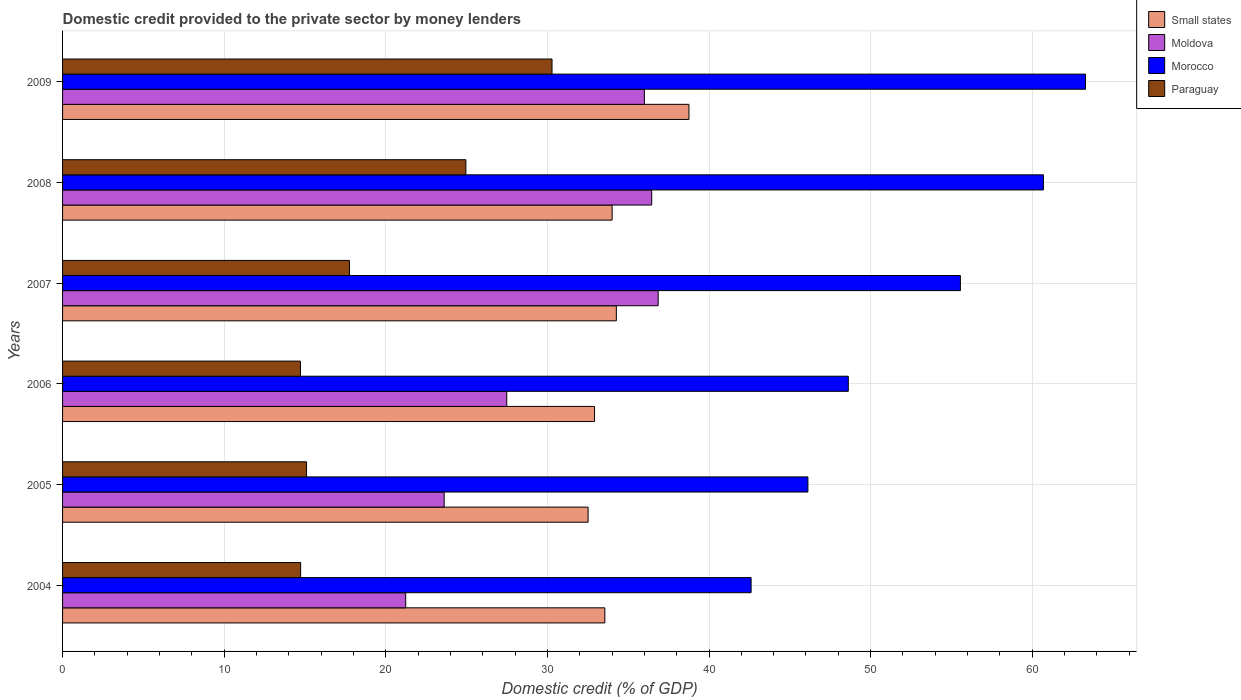How many groups of bars are there?
Your response must be concise. 6. Are the number of bars per tick equal to the number of legend labels?
Your response must be concise. Yes. How many bars are there on the 1st tick from the top?
Provide a succinct answer. 4. What is the domestic credit provided to the private sector by money lenders in Morocco in 2005?
Offer a very short reply. 46.12. Across all years, what is the maximum domestic credit provided to the private sector by money lenders in Small states?
Ensure brevity in your answer.  38.76. Across all years, what is the minimum domestic credit provided to the private sector by money lenders in Morocco?
Make the answer very short. 42.6. In which year was the domestic credit provided to the private sector by money lenders in Morocco maximum?
Offer a terse response. 2009. In which year was the domestic credit provided to the private sector by money lenders in Small states minimum?
Provide a succinct answer. 2005. What is the total domestic credit provided to the private sector by money lenders in Paraguay in the graph?
Your answer should be very brief. 117.55. What is the difference between the domestic credit provided to the private sector by money lenders in Paraguay in 2007 and that in 2009?
Your response must be concise. -12.53. What is the difference between the domestic credit provided to the private sector by money lenders in Paraguay in 2006 and the domestic credit provided to the private sector by money lenders in Small states in 2005?
Offer a terse response. -17.8. What is the average domestic credit provided to the private sector by money lenders in Moldova per year?
Ensure brevity in your answer.  30.27. In the year 2008, what is the difference between the domestic credit provided to the private sector by money lenders in Paraguay and domestic credit provided to the private sector by money lenders in Small states?
Ensure brevity in your answer.  -9.05. What is the ratio of the domestic credit provided to the private sector by money lenders in Moldova in 2005 to that in 2008?
Your response must be concise. 0.65. Is the domestic credit provided to the private sector by money lenders in Paraguay in 2005 less than that in 2007?
Offer a very short reply. Yes. Is the difference between the domestic credit provided to the private sector by money lenders in Paraguay in 2006 and 2009 greater than the difference between the domestic credit provided to the private sector by money lenders in Small states in 2006 and 2009?
Provide a succinct answer. No. What is the difference between the highest and the second highest domestic credit provided to the private sector by money lenders in Small states?
Offer a terse response. 4.49. What is the difference between the highest and the lowest domestic credit provided to the private sector by money lenders in Paraguay?
Give a very brief answer. 15.57. In how many years, is the domestic credit provided to the private sector by money lenders in Small states greater than the average domestic credit provided to the private sector by money lenders in Small states taken over all years?
Offer a very short reply. 1. Is it the case that in every year, the sum of the domestic credit provided to the private sector by money lenders in Moldova and domestic credit provided to the private sector by money lenders in Morocco is greater than the sum of domestic credit provided to the private sector by money lenders in Small states and domestic credit provided to the private sector by money lenders in Paraguay?
Your answer should be very brief. No. What does the 4th bar from the top in 2008 represents?
Your answer should be very brief. Small states. What does the 1st bar from the bottom in 2007 represents?
Your answer should be compact. Small states. Is it the case that in every year, the sum of the domestic credit provided to the private sector by money lenders in Small states and domestic credit provided to the private sector by money lenders in Morocco is greater than the domestic credit provided to the private sector by money lenders in Moldova?
Offer a terse response. Yes. Are all the bars in the graph horizontal?
Offer a terse response. Yes. How many years are there in the graph?
Provide a succinct answer. 6. What is the difference between two consecutive major ticks on the X-axis?
Your answer should be very brief. 10. Are the values on the major ticks of X-axis written in scientific E-notation?
Give a very brief answer. No. Does the graph contain any zero values?
Make the answer very short. No. Does the graph contain grids?
Your answer should be compact. Yes. Where does the legend appear in the graph?
Provide a short and direct response. Top right. How many legend labels are there?
Offer a very short reply. 4. How are the legend labels stacked?
Provide a succinct answer. Vertical. What is the title of the graph?
Your answer should be very brief. Domestic credit provided to the private sector by money lenders. What is the label or title of the X-axis?
Your response must be concise. Domestic credit (% of GDP). What is the label or title of the Y-axis?
Ensure brevity in your answer.  Years. What is the Domestic credit (% of GDP) in Small states in 2004?
Keep it short and to the point. 33.56. What is the Domestic credit (% of GDP) in Moldova in 2004?
Your answer should be very brief. 21.23. What is the Domestic credit (% of GDP) in Morocco in 2004?
Your answer should be compact. 42.6. What is the Domestic credit (% of GDP) of Paraguay in 2004?
Offer a very short reply. 14.73. What is the Domestic credit (% of GDP) of Small states in 2005?
Your answer should be very brief. 32.52. What is the Domestic credit (% of GDP) of Moldova in 2005?
Keep it short and to the point. 23.61. What is the Domestic credit (% of GDP) in Morocco in 2005?
Give a very brief answer. 46.12. What is the Domestic credit (% of GDP) of Paraguay in 2005?
Your response must be concise. 15.1. What is the Domestic credit (% of GDP) of Small states in 2006?
Ensure brevity in your answer.  32.92. What is the Domestic credit (% of GDP) of Moldova in 2006?
Offer a terse response. 27.48. What is the Domestic credit (% of GDP) in Morocco in 2006?
Give a very brief answer. 48.62. What is the Domestic credit (% of GDP) in Paraguay in 2006?
Offer a very short reply. 14.72. What is the Domestic credit (% of GDP) in Small states in 2007?
Your answer should be very brief. 34.27. What is the Domestic credit (% of GDP) in Moldova in 2007?
Your answer should be very brief. 36.86. What is the Domestic credit (% of GDP) of Morocco in 2007?
Ensure brevity in your answer.  55.55. What is the Domestic credit (% of GDP) of Paraguay in 2007?
Ensure brevity in your answer.  17.76. What is the Domestic credit (% of GDP) in Small states in 2008?
Make the answer very short. 34.01. What is the Domestic credit (% of GDP) of Moldova in 2008?
Offer a terse response. 36.46. What is the Domestic credit (% of GDP) of Morocco in 2008?
Provide a succinct answer. 60.69. What is the Domestic credit (% of GDP) in Paraguay in 2008?
Provide a short and direct response. 24.96. What is the Domestic credit (% of GDP) of Small states in 2009?
Keep it short and to the point. 38.76. What is the Domestic credit (% of GDP) of Moldova in 2009?
Make the answer very short. 36. What is the Domestic credit (% of GDP) of Morocco in 2009?
Offer a terse response. 63.3. What is the Domestic credit (% of GDP) in Paraguay in 2009?
Make the answer very short. 30.29. Across all years, what is the maximum Domestic credit (% of GDP) of Small states?
Provide a succinct answer. 38.76. Across all years, what is the maximum Domestic credit (% of GDP) in Moldova?
Keep it short and to the point. 36.86. Across all years, what is the maximum Domestic credit (% of GDP) in Morocco?
Give a very brief answer. 63.3. Across all years, what is the maximum Domestic credit (% of GDP) of Paraguay?
Offer a very short reply. 30.29. Across all years, what is the minimum Domestic credit (% of GDP) of Small states?
Offer a terse response. 32.52. Across all years, what is the minimum Domestic credit (% of GDP) in Moldova?
Keep it short and to the point. 21.23. Across all years, what is the minimum Domestic credit (% of GDP) in Morocco?
Offer a terse response. 42.6. Across all years, what is the minimum Domestic credit (% of GDP) of Paraguay?
Provide a succinct answer. 14.72. What is the total Domestic credit (% of GDP) in Small states in the graph?
Offer a very short reply. 206.03. What is the total Domestic credit (% of GDP) of Moldova in the graph?
Give a very brief answer. 181.64. What is the total Domestic credit (% of GDP) in Morocco in the graph?
Provide a succinct answer. 316.89. What is the total Domestic credit (% of GDP) of Paraguay in the graph?
Your answer should be compact. 117.55. What is the difference between the Domestic credit (% of GDP) in Small states in 2004 and that in 2005?
Offer a very short reply. 1.04. What is the difference between the Domestic credit (% of GDP) of Moldova in 2004 and that in 2005?
Ensure brevity in your answer.  -2.38. What is the difference between the Domestic credit (% of GDP) in Morocco in 2004 and that in 2005?
Give a very brief answer. -3.52. What is the difference between the Domestic credit (% of GDP) of Paraguay in 2004 and that in 2005?
Give a very brief answer. -0.37. What is the difference between the Domestic credit (% of GDP) of Small states in 2004 and that in 2006?
Your answer should be compact. 0.64. What is the difference between the Domestic credit (% of GDP) in Moldova in 2004 and that in 2006?
Keep it short and to the point. -6.25. What is the difference between the Domestic credit (% of GDP) in Morocco in 2004 and that in 2006?
Your response must be concise. -6.02. What is the difference between the Domestic credit (% of GDP) in Paraguay in 2004 and that in 2006?
Your answer should be very brief. 0.01. What is the difference between the Domestic credit (% of GDP) of Small states in 2004 and that in 2007?
Ensure brevity in your answer.  -0.71. What is the difference between the Domestic credit (% of GDP) in Moldova in 2004 and that in 2007?
Provide a short and direct response. -15.62. What is the difference between the Domestic credit (% of GDP) in Morocco in 2004 and that in 2007?
Provide a succinct answer. -12.95. What is the difference between the Domestic credit (% of GDP) in Paraguay in 2004 and that in 2007?
Your answer should be very brief. -3.02. What is the difference between the Domestic credit (% of GDP) in Small states in 2004 and that in 2008?
Provide a succinct answer. -0.45. What is the difference between the Domestic credit (% of GDP) of Moldova in 2004 and that in 2008?
Make the answer very short. -15.22. What is the difference between the Domestic credit (% of GDP) of Morocco in 2004 and that in 2008?
Offer a terse response. -18.09. What is the difference between the Domestic credit (% of GDP) of Paraguay in 2004 and that in 2008?
Provide a succinct answer. -10.23. What is the difference between the Domestic credit (% of GDP) of Small states in 2004 and that in 2009?
Your response must be concise. -5.2. What is the difference between the Domestic credit (% of GDP) in Moldova in 2004 and that in 2009?
Keep it short and to the point. -14.77. What is the difference between the Domestic credit (% of GDP) in Morocco in 2004 and that in 2009?
Your response must be concise. -20.69. What is the difference between the Domestic credit (% of GDP) of Paraguay in 2004 and that in 2009?
Provide a short and direct response. -15.56. What is the difference between the Domestic credit (% of GDP) in Small states in 2005 and that in 2006?
Your answer should be very brief. -0.4. What is the difference between the Domestic credit (% of GDP) of Moldova in 2005 and that in 2006?
Keep it short and to the point. -3.87. What is the difference between the Domestic credit (% of GDP) of Morocco in 2005 and that in 2006?
Provide a succinct answer. -2.5. What is the difference between the Domestic credit (% of GDP) of Paraguay in 2005 and that in 2006?
Provide a short and direct response. 0.38. What is the difference between the Domestic credit (% of GDP) in Small states in 2005 and that in 2007?
Your answer should be compact. -1.75. What is the difference between the Domestic credit (% of GDP) of Moldova in 2005 and that in 2007?
Offer a terse response. -13.24. What is the difference between the Domestic credit (% of GDP) in Morocco in 2005 and that in 2007?
Your response must be concise. -9.43. What is the difference between the Domestic credit (% of GDP) in Paraguay in 2005 and that in 2007?
Give a very brief answer. -2.66. What is the difference between the Domestic credit (% of GDP) of Small states in 2005 and that in 2008?
Offer a very short reply. -1.49. What is the difference between the Domestic credit (% of GDP) in Moldova in 2005 and that in 2008?
Make the answer very short. -12.84. What is the difference between the Domestic credit (% of GDP) in Morocco in 2005 and that in 2008?
Offer a very short reply. -14.57. What is the difference between the Domestic credit (% of GDP) of Paraguay in 2005 and that in 2008?
Provide a succinct answer. -9.86. What is the difference between the Domestic credit (% of GDP) of Small states in 2005 and that in 2009?
Your response must be concise. -6.24. What is the difference between the Domestic credit (% of GDP) in Moldova in 2005 and that in 2009?
Your answer should be very brief. -12.39. What is the difference between the Domestic credit (% of GDP) in Morocco in 2005 and that in 2009?
Your answer should be very brief. -17.18. What is the difference between the Domestic credit (% of GDP) of Paraguay in 2005 and that in 2009?
Keep it short and to the point. -15.19. What is the difference between the Domestic credit (% of GDP) in Small states in 2006 and that in 2007?
Ensure brevity in your answer.  -1.35. What is the difference between the Domestic credit (% of GDP) in Moldova in 2006 and that in 2007?
Offer a terse response. -9.37. What is the difference between the Domestic credit (% of GDP) of Morocco in 2006 and that in 2007?
Provide a succinct answer. -6.93. What is the difference between the Domestic credit (% of GDP) of Paraguay in 2006 and that in 2007?
Your answer should be very brief. -3.04. What is the difference between the Domestic credit (% of GDP) in Small states in 2006 and that in 2008?
Provide a succinct answer. -1.09. What is the difference between the Domestic credit (% of GDP) in Moldova in 2006 and that in 2008?
Keep it short and to the point. -8.97. What is the difference between the Domestic credit (% of GDP) in Morocco in 2006 and that in 2008?
Offer a terse response. -12.07. What is the difference between the Domestic credit (% of GDP) in Paraguay in 2006 and that in 2008?
Your response must be concise. -10.24. What is the difference between the Domestic credit (% of GDP) in Small states in 2006 and that in 2009?
Give a very brief answer. -5.84. What is the difference between the Domestic credit (% of GDP) in Moldova in 2006 and that in 2009?
Keep it short and to the point. -8.52. What is the difference between the Domestic credit (% of GDP) of Morocco in 2006 and that in 2009?
Give a very brief answer. -14.68. What is the difference between the Domestic credit (% of GDP) of Paraguay in 2006 and that in 2009?
Offer a terse response. -15.57. What is the difference between the Domestic credit (% of GDP) in Small states in 2007 and that in 2008?
Keep it short and to the point. 0.26. What is the difference between the Domestic credit (% of GDP) in Moldova in 2007 and that in 2008?
Provide a short and direct response. 0.4. What is the difference between the Domestic credit (% of GDP) in Morocco in 2007 and that in 2008?
Make the answer very short. -5.14. What is the difference between the Domestic credit (% of GDP) of Paraguay in 2007 and that in 2008?
Your answer should be very brief. -7.2. What is the difference between the Domestic credit (% of GDP) of Small states in 2007 and that in 2009?
Ensure brevity in your answer.  -4.49. What is the difference between the Domestic credit (% of GDP) in Moldova in 2007 and that in 2009?
Provide a short and direct response. 0.85. What is the difference between the Domestic credit (% of GDP) in Morocco in 2007 and that in 2009?
Offer a terse response. -7.74. What is the difference between the Domestic credit (% of GDP) of Paraguay in 2007 and that in 2009?
Your response must be concise. -12.53. What is the difference between the Domestic credit (% of GDP) in Small states in 2008 and that in 2009?
Your answer should be very brief. -4.75. What is the difference between the Domestic credit (% of GDP) in Moldova in 2008 and that in 2009?
Ensure brevity in your answer.  0.45. What is the difference between the Domestic credit (% of GDP) of Morocco in 2008 and that in 2009?
Your response must be concise. -2.6. What is the difference between the Domestic credit (% of GDP) in Paraguay in 2008 and that in 2009?
Offer a terse response. -5.33. What is the difference between the Domestic credit (% of GDP) in Small states in 2004 and the Domestic credit (% of GDP) in Moldova in 2005?
Your answer should be very brief. 9.94. What is the difference between the Domestic credit (% of GDP) of Small states in 2004 and the Domestic credit (% of GDP) of Morocco in 2005?
Your answer should be very brief. -12.56. What is the difference between the Domestic credit (% of GDP) in Small states in 2004 and the Domestic credit (% of GDP) in Paraguay in 2005?
Ensure brevity in your answer.  18.46. What is the difference between the Domestic credit (% of GDP) in Moldova in 2004 and the Domestic credit (% of GDP) in Morocco in 2005?
Offer a terse response. -24.89. What is the difference between the Domestic credit (% of GDP) in Moldova in 2004 and the Domestic credit (% of GDP) in Paraguay in 2005?
Offer a very short reply. 6.13. What is the difference between the Domestic credit (% of GDP) in Morocco in 2004 and the Domestic credit (% of GDP) in Paraguay in 2005?
Make the answer very short. 27.51. What is the difference between the Domestic credit (% of GDP) in Small states in 2004 and the Domestic credit (% of GDP) in Moldova in 2006?
Your answer should be compact. 6.07. What is the difference between the Domestic credit (% of GDP) of Small states in 2004 and the Domestic credit (% of GDP) of Morocco in 2006?
Your answer should be very brief. -15.06. What is the difference between the Domestic credit (% of GDP) of Small states in 2004 and the Domestic credit (% of GDP) of Paraguay in 2006?
Your response must be concise. 18.84. What is the difference between the Domestic credit (% of GDP) in Moldova in 2004 and the Domestic credit (% of GDP) in Morocco in 2006?
Your answer should be very brief. -27.39. What is the difference between the Domestic credit (% of GDP) of Moldova in 2004 and the Domestic credit (% of GDP) of Paraguay in 2006?
Your answer should be very brief. 6.51. What is the difference between the Domestic credit (% of GDP) in Morocco in 2004 and the Domestic credit (% of GDP) in Paraguay in 2006?
Offer a terse response. 27.89. What is the difference between the Domestic credit (% of GDP) of Small states in 2004 and the Domestic credit (% of GDP) of Moldova in 2007?
Provide a succinct answer. -3.3. What is the difference between the Domestic credit (% of GDP) in Small states in 2004 and the Domestic credit (% of GDP) in Morocco in 2007?
Ensure brevity in your answer.  -22. What is the difference between the Domestic credit (% of GDP) in Small states in 2004 and the Domestic credit (% of GDP) in Paraguay in 2007?
Offer a very short reply. 15.8. What is the difference between the Domestic credit (% of GDP) in Moldova in 2004 and the Domestic credit (% of GDP) in Morocco in 2007?
Offer a terse response. -34.32. What is the difference between the Domestic credit (% of GDP) in Moldova in 2004 and the Domestic credit (% of GDP) in Paraguay in 2007?
Your response must be concise. 3.47. What is the difference between the Domestic credit (% of GDP) of Morocco in 2004 and the Domestic credit (% of GDP) of Paraguay in 2007?
Your answer should be very brief. 24.85. What is the difference between the Domestic credit (% of GDP) in Small states in 2004 and the Domestic credit (% of GDP) in Moldova in 2008?
Your answer should be very brief. -2.9. What is the difference between the Domestic credit (% of GDP) of Small states in 2004 and the Domestic credit (% of GDP) of Morocco in 2008?
Make the answer very short. -27.14. What is the difference between the Domestic credit (% of GDP) of Small states in 2004 and the Domestic credit (% of GDP) of Paraguay in 2008?
Your answer should be very brief. 8.6. What is the difference between the Domestic credit (% of GDP) in Moldova in 2004 and the Domestic credit (% of GDP) in Morocco in 2008?
Your answer should be very brief. -39.46. What is the difference between the Domestic credit (% of GDP) in Moldova in 2004 and the Domestic credit (% of GDP) in Paraguay in 2008?
Provide a short and direct response. -3.73. What is the difference between the Domestic credit (% of GDP) in Morocco in 2004 and the Domestic credit (% of GDP) in Paraguay in 2008?
Offer a terse response. 17.65. What is the difference between the Domestic credit (% of GDP) in Small states in 2004 and the Domestic credit (% of GDP) in Moldova in 2009?
Give a very brief answer. -2.45. What is the difference between the Domestic credit (% of GDP) in Small states in 2004 and the Domestic credit (% of GDP) in Morocco in 2009?
Ensure brevity in your answer.  -29.74. What is the difference between the Domestic credit (% of GDP) of Small states in 2004 and the Domestic credit (% of GDP) of Paraguay in 2009?
Your response must be concise. 3.27. What is the difference between the Domestic credit (% of GDP) of Moldova in 2004 and the Domestic credit (% of GDP) of Morocco in 2009?
Offer a very short reply. -42.07. What is the difference between the Domestic credit (% of GDP) in Moldova in 2004 and the Domestic credit (% of GDP) in Paraguay in 2009?
Keep it short and to the point. -9.06. What is the difference between the Domestic credit (% of GDP) of Morocco in 2004 and the Domestic credit (% of GDP) of Paraguay in 2009?
Offer a very short reply. 12.32. What is the difference between the Domestic credit (% of GDP) in Small states in 2005 and the Domestic credit (% of GDP) in Moldova in 2006?
Provide a succinct answer. 5.03. What is the difference between the Domestic credit (% of GDP) in Small states in 2005 and the Domestic credit (% of GDP) in Morocco in 2006?
Keep it short and to the point. -16.1. What is the difference between the Domestic credit (% of GDP) in Small states in 2005 and the Domestic credit (% of GDP) in Paraguay in 2006?
Offer a very short reply. 17.8. What is the difference between the Domestic credit (% of GDP) in Moldova in 2005 and the Domestic credit (% of GDP) in Morocco in 2006?
Provide a short and direct response. -25.01. What is the difference between the Domestic credit (% of GDP) in Moldova in 2005 and the Domestic credit (% of GDP) in Paraguay in 2006?
Your answer should be very brief. 8.89. What is the difference between the Domestic credit (% of GDP) in Morocco in 2005 and the Domestic credit (% of GDP) in Paraguay in 2006?
Your answer should be very brief. 31.4. What is the difference between the Domestic credit (% of GDP) in Small states in 2005 and the Domestic credit (% of GDP) in Moldova in 2007?
Give a very brief answer. -4.34. What is the difference between the Domestic credit (% of GDP) in Small states in 2005 and the Domestic credit (% of GDP) in Morocco in 2007?
Your answer should be very brief. -23.04. What is the difference between the Domestic credit (% of GDP) in Small states in 2005 and the Domestic credit (% of GDP) in Paraguay in 2007?
Offer a very short reply. 14.76. What is the difference between the Domestic credit (% of GDP) in Moldova in 2005 and the Domestic credit (% of GDP) in Morocco in 2007?
Your answer should be compact. -31.94. What is the difference between the Domestic credit (% of GDP) in Moldova in 2005 and the Domestic credit (% of GDP) in Paraguay in 2007?
Provide a succinct answer. 5.86. What is the difference between the Domestic credit (% of GDP) in Morocco in 2005 and the Domestic credit (% of GDP) in Paraguay in 2007?
Your response must be concise. 28.36. What is the difference between the Domestic credit (% of GDP) in Small states in 2005 and the Domestic credit (% of GDP) in Moldova in 2008?
Your response must be concise. -3.94. What is the difference between the Domestic credit (% of GDP) in Small states in 2005 and the Domestic credit (% of GDP) in Morocco in 2008?
Keep it short and to the point. -28.18. What is the difference between the Domestic credit (% of GDP) in Small states in 2005 and the Domestic credit (% of GDP) in Paraguay in 2008?
Offer a very short reply. 7.56. What is the difference between the Domestic credit (% of GDP) of Moldova in 2005 and the Domestic credit (% of GDP) of Morocco in 2008?
Offer a very short reply. -37.08. What is the difference between the Domestic credit (% of GDP) of Moldova in 2005 and the Domestic credit (% of GDP) of Paraguay in 2008?
Your answer should be very brief. -1.34. What is the difference between the Domestic credit (% of GDP) of Morocco in 2005 and the Domestic credit (% of GDP) of Paraguay in 2008?
Make the answer very short. 21.16. What is the difference between the Domestic credit (% of GDP) in Small states in 2005 and the Domestic credit (% of GDP) in Moldova in 2009?
Offer a terse response. -3.48. What is the difference between the Domestic credit (% of GDP) of Small states in 2005 and the Domestic credit (% of GDP) of Morocco in 2009?
Provide a short and direct response. -30.78. What is the difference between the Domestic credit (% of GDP) in Small states in 2005 and the Domestic credit (% of GDP) in Paraguay in 2009?
Offer a very short reply. 2.23. What is the difference between the Domestic credit (% of GDP) of Moldova in 2005 and the Domestic credit (% of GDP) of Morocco in 2009?
Your answer should be very brief. -39.68. What is the difference between the Domestic credit (% of GDP) of Moldova in 2005 and the Domestic credit (% of GDP) of Paraguay in 2009?
Your response must be concise. -6.67. What is the difference between the Domestic credit (% of GDP) of Morocco in 2005 and the Domestic credit (% of GDP) of Paraguay in 2009?
Your answer should be very brief. 15.83. What is the difference between the Domestic credit (% of GDP) in Small states in 2006 and the Domestic credit (% of GDP) in Moldova in 2007?
Offer a terse response. -3.94. What is the difference between the Domestic credit (% of GDP) of Small states in 2006 and the Domestic credit (% of GDP) of Morocco in 2007?
Provide a short and direct response. -22.64. What is the difference between the Domestic credit (% of GDP) of Small states in 2006 and the Domestic credit (% of GDP) of Paraguay in 2007?
Give a very brief answer. 15.16. What is the difference between the Domestic credit (% of GDP) in Moldova in 2006 and the Domestic credit (% of GDP) in Morocco in 2007?
Make the answer very short. -28.07. What is the difference between the Domestic credit (% of GDP) in Moldova in 2006 and the Domestic credit (% of GDP) in Paraguay in 2007?
Ensure brevity in your answer.  9.73. What is the difference between the Domestic credit (% of GDP) of Morocco in 2006 and the Domestic credit (% of GDP) of Paraguay in 2007?
Provide a succinct answer. 30.86. What is the difference between the Domestic credit (% of GDP) of Small states in 2006 and the Domestic credit (% of GDP) of Moldova in 2008?
Your answer should be very brief. -3.54. What is the difference between the Domestic credit (% of GDP) in Small states in 2006 and the Domestic credit (% of GDP) in Morocco in 2008?
Offer a terse response. -27.78. What is the difference between the Domestic credit (% of GDP) in Small states in 2006 and the Domestic credit (% of GDP) in Paraguay in 2008?
Your answer should be compact. 7.96. What is the difference between the Domestic credit (% of GDP) in Moldova in 2006 and the Domestic credit (% of GDP) in Morocco in 2008?
Ensure brevity in your answer.  -33.21. What is the difference between the Domestic credit (% of GDP) of Moldova in 2006 and the Domestic credit (% of GDP) of Paraguay in 2008?
Offer a terse response. 2.53. What is the difference between the Domestic credit (% of GDP) of Morocco in 2006 and the Domestic credit (% of GDP) of Paraguay in 2008?
Your response must be concise. 23.66. What is the difference between the Domestic credit (% of GDP) in Small states in 2006 and the Domestic credit (% of GDP) in Moldova in 2009?
Your answer should be compact. -3.09. What is the difference between the Domestic credit (% of GDP) in Small states in 2006 and the Domestic credit (% of GDP) in Morocco in 2009?
Give a very brief answer. -30.38. What is the difference between the Domestic credit (% of GDP) of Small states in 2006 and the Domestic credit (% of GDP) of Paraguay in 2009?
Provide a short and direct response. 2.63. What is the difference between the Domestic credit (% of GDP) in Moldova in 2006 and the Domestic credit (% of GDP) in Morocco in 2009?
Provide a short and direct response. -35.81. What is the difference between the Domestic credit (% of GDP) of Moldova in 2006 and the Domestic credit (% of GDP) of Paraguay in 2009?
Your response must be concise. -2.8. What is the difference between the Domestic credit (% of GDP) in Morocco in 2006 and the Domestic credit (% of GDP) in Paraguay in 2009?
Make the answer very short. 18.33. What is the difference between the Domestic credit (% of GDP) of Small states in 2007 and the Domestic credit (% of GDP) of Moldova in 2008?
Offer a very short reply. -2.19. What is the difference between the Domestic credit (% of GDP) of Small states in 2007 and the Domestic credit (% of GDP) of Morocco in 2008?
Make the answer very short. -26.43. What is the difference between the Domestic credit (% of GDP) of Small states in 2007 and the Domestic credit (% of GDP) of Paraguay in 2008?
Keep it short and to the point. 9.31. What is the difference between the Domestic credit (% of GDP) of Moldova in 2007 and the Domestic credit (% of GDP) of Morocco in 2008?
Keep it short and to the point. -23.84. What is the difference between the Domestic credit (% of GDP) of Moldova in 2007 and the Domestic credit (% of GDP) of Paraguay in 2008?
Provide a succinct answer. 11.9. What is the difference between the Domestic credit (% of GDP) in Morocco in 2007 and the Domestic credit (% of GDP) in Paraguay in 2008?
Provide a succinct answer. 30.6. What is the difference between the Domestic credit (% of GDP) of Small states in 2007 and the Domestic credit (% of GDP) of Moldova in 2009?
Your answer should be very brief. -1.74. What is the difference between the Domestic credit (% of GDP) of Small states in 2007 and the Domestic credit (% of GDP) of Morocco in 2009?
Offer a very short reply. -29.03. What is the difference between the Domestic credit (% of GDP) of Small states in 2007 and the Domestic credit (% of GDP) of Paraguay in 2009?
Make the answer very short. 3.98. What is the difference between the Domestic credit (% of GDP) of Moldova in 2007 and the Domestic credit (% of GDP) of Morocco in 2009?
Your answer should be compact. -26.44. What is the difference between the Domestic credit (% of GDP) of Moldova in 2007 and the Domestic credit (% of GDP) of Paraguay in 2009?
Your response must be concise. 6.57. What is the difference between the Domestic credit (% of GDP) of Morocco in 2007 and the Domestic credit (% of GDP) of Paraguay in 2009?
Your response must be concise. 25.27. What is the difference between the Domestic credit (% of GDP) of Small states in 2008 and the Domestic credit (% of GDP) of Moldova in 2009?
Your answer should be compact. -2. What is the difference between the Domestic credit (% of GDP) of Small states in 2008 and the Domestic credit (% of GDP) of Morocco in 2009?
Your answer should be very brief. -29.29. What is the difference between the Domestic credit (% of GDP) of Small states in 2008 and the Domestic credit (% of GDP) of Paraguay in 2009?
Give a very brief answer. 3.72. What is the difference between the Domestic credit (% of GDP) in Moldova in 2008 and the Domestic credit (% of GDP) in Morocco in 2009?
Provide a short and direct response. -26.84. What is the difference between the Domestic credit (% of GDP) in Moldova in 2008 and the Domestic credit (% of GDP) in Paraguay in 2009?
Make the answer very short. 6.17. What is the difference between the Domestic credit (% of GDP) of Morocco in 2008 and the Domestic credit (% of GDP) of Paraguay in 2009?
Ensure brevity in your answer.  30.41. What is the average Domestic credit (% of GDP) in Small states per year?
Your answer should be compact. 34.34. What is the average Domestic credit (% of GDP) in Moldova per year?
Provide a short and direct response. 30.27. What is the average Domestic credit (% of GDP) in Morocco per year?
Your response must be concise. 52.82. What is the average Domestic credit (% of GDP) of Paraguay per year?
Keep it short and to the point. 19.59. In the year 2004, what is the difference between the Domestic credit (% of GDP) in Small states and Domestic credit (% of GDP) in Moldova?
Offer a terse response. 12.33. In the year 2004, what is the difference between the Domestic credit (% of GDP) of Small states and Domestic credit (% of GDP) of Morocco?
Give a very brief answer. -9.05. In the year 2004, what is the difference between the Domestic credit (% of GDP) of Small states and Domestic credit (% of GDP) of Paraguay?
Make the answer very short. 18.82. In the year 2004, what is the difference between the Domestic credit (% of GDP) of Moldova and Domestic credit (% of GDP) of Morocco?
Your answer should be very brief. -21.37. In the year 2004, what is the difference between the Domestic credit (% of GDP) of Moldova and Domestic credit (% of GDP) of Paraguay?
Keep it short and to the point. 6.5. In the year 2004, what is the difference between the Domestic credit (% of GDP) of Morocco and Domestic credit (% of GDP) of Paraguay?
Offer a terse response. 27.87. In the year 2005, what is the difference between the Domestic credit (% of GDP) of Small states and Domestic credit (% of GDP) of Moldova?
Offer a terse response. 8.9. In the year 2005, what is the difference between the Domestic credit (% of GDP) in Small states and Domestic credit (% of GDP) in Morocco?
Your answer should be compact. -13.6. In the year 2005, what is the difference between the Domestic credit (% of GDP) of Small states and Domestic credit (% of GDP) of Paraguay?
Make the answer very short. 17.42. In the year 2005, what is the difference between the Domestic credit (% of GDP) in Moldova and Domestic credit (% of GDP) in Morocco?
Provide a short and direct response. -22.51. In the year 2005, what is the difference between the Domestic credit (% of GDP) of Moldova and Domestic credit (% of GDP) of Paraguay?
Keep it short and to the point. 8.52. In the year 2005, what is the difference between the Domestic credit (% of GDP) of Morocco and Domestic credit (% of GDP) of Paraguay?
Your answer should be compact. 31.02. In the year 2006, what is the difference between the Domestic credit (% of GDP) in Small states and Domestic credit (% of GDP) in Moldova?
Your response must be concise. 5.43. In the year 2006, what is the difference between the Domestic credit (% of GDP) of Small states and Domestic credit (% of GDP) of Morocco?
Make the answer very short. -15.7. In the year 2006, what is the difference between the Domestic credit (% of GDP) of Small states and Domestic credit (% of GDP) of Paraguay?
Provide a succinct answer. 18.2. In the year 2006, what is the difference between the Domestic credit (% of GDP) of Moldova and Domestic credit (% of GDP) of Morocco?
Give a very brief answer. -21.14. In the year 2006, what is the difference between the Domestic credit (% of GDP) of Moldova and Domestic credit (% of GDP) of Paraguay?
Provide a succinct answer. 12.77. In the year 2006, what is the difference between the Domestic credit (% of GDP) of Morocco and Domestic credit (% of GDP) of Paraguay?
Ensure brevity in your answer.  33.9. In the year 2007, what is the difference between the Domestic credit (% of GDP) in Small states and Domestic credit (% of GDP) in Moldova?
Ensure brevity in your answer.  -2.59. In the year 2007, what is the difference between the Domestic credit (% of GDP) of Small states and Domestic credit (% of GDP) of Morocco?
Your answer should be compact. -21.29. In the year 2007, what is the difference between the Domestic credit (% of GDP) of Small states and Domestic credit (% of GDP) of Paraguay?
Give a very brief answer. 16.51. In the year 2007, what is the difference between the Domestic credit (% of GDP) of Moldova and Domestic credit (% of GDP) of Morocco?
Provide a short and direct response. -18.7. In the year 2007, what is the difference between the Domestic credit (% of GDP) in Moldova and Domestic credit (% of GDP) in Paraguay?
Provide a short and direct response. 19.1. In the year 2007, what is the difference between the Domestic credit (% of GDP) of Morocco and Domestic credit (% of GDP) of Paraguay?
Give a very brief answer. 37.8. In the year 2008, what is the difference between the Domestic credit (% of GDP) in Small states and Domestic credit (% of GDP) in Moldova?
Provide a short and direct response. -2.45. In the year 2008, what is the difference between the Domestic credit (% of GDP) in Small states and Domestic credit (% of GDP) in Morocco?
Give a very brief answer. -26.69. In the year 2008, what is the difference between the Domestic credit (% of GDP) of Small states and Domestic credit (% of GDP) of Paraguay?
Give a very brief answer. 9.05. In the year 2008, what is the difference between the Domestic credit (% of GDP) of Moldova and Domestic credit (% of GDP) of Morocco?
Your answer should be very brief. -24.24. In the year 2008, what is the difference between the Domestic credit (% of GDP) in Moldova and Domestic credit (% of GDP) in Paraguay?
Offer a terse response. 11.5. In the year 2008, what is the difference between the Domestic credit (% of GDP) of Morocco and Domestic credit (% of GDP) of Paraguay?
Offer a terse response. 35.74. In the year 2009, what is the difference between the Domestic credit (% of GDP) in Small states and Domestic credit (% of GDP) in Moldova?
Make the answer very short. 2.76. In the year 2009, what is the difference between the Domestic credit (% of GDP) in Small states and Domestic credit (% of GDP) in Morocco?
Provide a short and direct response. -24.54. In the year 2009, what is the difference between the Domestic credit (% of GDP) in Small states and Domestic credit (% of GDP) in Paraguay?
Keep it short and to the point. 8.47. In the year 2009, what is the difference between the Domestic credit (% of GDP) of Moldova and Domestic credit (% of GDP) of Morocco?
Provide a short and direct response. -27.3. In the year 2009, what is the difference between the Domestic credit (% of GDP) in Moldova and Domestic credit (% of GDP) in Paraguay?
Your answer should be compact. 5.72. In the year 2009, what is the difference between the Domestic credit (% of GDP) of Morocco and Domestic credit (% of GDP) of Paraguay?
Your answer should be compact. 33.01. What is the ratio of the Domestic credit (% of GDP) in Small states in 2004 to that in 2005?
Offer a very short reply. 1.03. What is the ratio of the Domestic credit (% of GDP) of Moldova in 2004 to that in 2005?
Offer a terse response. 0.9. What is the ratio of the Domestic credit (% of GDP) in Morocco in 2004 to that in 2005?
Offer a terse response. 0.92. What is the ratio of the Domestic credit (% of GDP) of Paraguay in 2004 to that in 2005?
Ensure brevity in your answer.  0.98. What is the ratio of the Domestic credit (% of GDP) in Small states in 2004 to that in 2006?
Keep it short and to the point. 1.02. What is the ratio of the Domestic credit (% of GDP) of Moldova in 2004 to that in 2006?
Provide a short and direct response. 0.77. What is the ratio of the Domestic credit (% of GDP) of Morocco in 2004 to that in 2006?
Your answer should be very brief. 0.88. What is the ratio of the Domestic credit (% of GDP) in Small states in 2004 to that in 2007?
Your answer should be very brief. 0.98. What is the ratio of the Domestic credit (% of GDP) of Moldova in 2004 to that in 2007?
Offer a terse response. 0.58. What is the ratio of the Domestic credit (% of GDP) in Morocco in 2004 to that in 2007?
Keep it short and to the point. 0.77. What is the ratio of the Domestic credit (% of GDP) in Paraguay in 2004 to that in 2007?
Ensure brevity in your answer.  0.83. What is the ratio of the Domestic credit (% of GDP) in Small states in 2004 to that in 2008?
Give a very brief answer. 0.99. What is the ratio of the Domestic credit (% of GDP) in Moldova in 2004 to that in 2008?
Keep it short and to the point. 0.58. What is the ratio of the Domestic credit (% of GDP) of Morocco in 2004 to that in 2008?
Make the answer very short. 0.7. What is the ratio of the Domestic credit (% of GDP) in Paraguay in 2004 to that in 2008?
Ensure brevity in your answer.  0.59. What is the ratio of the Domestic credit (% of GDP) of Small states in 2004 to that in 2009?
Your answer should be compact. 0.87. What is the ratio of the Domestic credit (% of GDP) of Moldova in 2004 to that in 2009?
Your answer should be compact. 0.59. What is the ratio of the Domestic credit (% of GDP) in Morocco in 2004 to that in 2009?
Offer a terse response. 0.67. What is the ratio of the Domestic credit (% of GDP) of Paraguay in 2004 to that in 2009?
Make the answer very short. 0.49. What is the ratio of the Domestic credit (% of GDP) of Small states in 2005 to that in 2006?
Offer a terse response. 0.99. What is the ratio of the Domestic credit (% of GDP) in Moldova in 2005 to that in 2006?
Keep it short and to the point. 0.86. What is the ratio of the Domestic credit (% of GDP) of Morocco in 2005 to that in 2006?
Your answer should be very brief. 0.95. What is the ratio of the Domestic credit (% of GDP) in Paraguay in 2005 to that in 2006?
Your answer should be compact. 1.03. What is the ratio of the Domestic credit (% of GDP) in Small states in 2005 to that in 2007?
Keep it short and to the point. 0.95. What is the ratio of the Domestic credit (% of GDP) in Moldova in 2005 to that in 2007?
Offer a terse response. 0.64. What is the ratio of the Domestic credit (% of GDP) of Morocco in 2005 to that in 2007?
Make the answer very short. 0.83. What is the ratio of the Domestic credit (% of GDP) in Paraguay in 2005 to that in 2007?
Provide a short and direct response. 0.85. What is the ratio of the Domestic credit (% of GDP) in Small states in 2005 to that in 2008?
Offer a very short reply. 0.96. What is the ratio of the Domestic credit (% of GDP) in Moldova in 2005 to that in 2008?
Your answer should be compact. 0.65. What is the ratio of the Domestic credit (% of GDP) in Morocco in 2005 to that in 2008?
Provide a succinct answer. 0.76. What is the ratio of the Domestic credit (% of GDP) in Paraguay in 2005 to that in 2008?
Your response must be concise. 0.6. What is the ratio of the Domestic credit (% of GDP) of Small states in 2005 to that in 2009?
Keep it short and to the point. 0.84. What is the ratio of the Domestic credit (% of GDP) in Moldova in 2005 to that in 2009?
Offer a very short reply. 0.66. What is the ratio of the Domestic credit (% of GDP) in Morocco in 2005 to that in 2009?
Provide a succinct answer. 0.73. What is the ratio of the Domestic credit (% of GDP) of Paraguay in 2005 to that in 2009?
Keep it short and to the point. 0.5. What is the ratio of the Domestic credit (% of GDP) of Small states in 2006 to that in 2007?
Ensure brevity in your answer.  0.96. What is the ratio of the Domestic credit (% of GDP) in Moldova in 2006 to that in 2007?
Provide a short and direct response. 0.75. What is the ratio of the Domestic credit (% of GDP) of Morocco in 2006 to that in 2007?
Give a very brief answer. 0.88. What is the ratio of the Domestic credit (% of GDP) of Paraguay in 2006 to that in 2007?
Give a very brief answer. 0.83. What is the ratio of the Domestic credit (% of GDP) of Small states in 2006 to that in 2008?
Provide a short and direct response. 0.97. What is the ratio of the Domestic credit (% of GDP) in Moldova in 2006 to that in 2008?
Provide a succinct answer. 0.75. What is the ratio of the Domestic credit (% of GDP) in Morocco in 2006 to that in 2008?
Provide a succinct answer. 0.8. What is the ratio of the Domestic credit (% of GDP) in Paraguay in 2006 to that in 2008?
Provide a short and direct response. 0.59. What is the ratio of the Domestic credit (% of GDP) in Small states in 2006 to that in 2009?
Keep it short and to the point. 0.85. What is the ratio of the Domestic credit (% of GDP) in Moldova in 2006 to that in 2009?
Your answer should be very brief. 0.76. What is the ratio of the Domestic credit (% of GDP) in Morocco in 2006 to that in 2009?
Give a very brief answer. 0.77. What is the ratio of the Domestic credit (% of GDP) of Paraguay in 2006 to that in 2009?
Give a very brief answer. 0.49. What is the ratio of the Domestic credit (% of GDP) in Small states in 2007 to that in 2008?
Your response must be concise. 1.01. What is the ratio of the Domestic credit (% of GDP) in Morocco in 2007 to that in 2008?
Offer a terse response. 0.92. What is the ratio of the Domestic credit (% of GDP) in Paraguay in 2007 to that in 2008?
Give a very brief answer. 0.71. What is the ratio of the Domestic credit (% of GDP) of Small states in 2007 to that in 2009?
Your response must be concise. 0.88. What is the ratio of the Domestic credit (% of GDP) in Moldova in 2007 to that in 2009?
Provide a succinct answer. 1.02. What is the ratio of the Domestic credit (% of GDP) in Morocco in 2007 to that in 2009?
Offer a very short reply. 0.88. What is the ratio of the Domestic credit (% of GDP) of Paraguay in 2007 to that in 2009?
Your answer should be very brief. 0.59. What is the ratio of the Domestic credit (% of GDP) of Small states in 2008 to that in 2009?
Provide a short and direct response. 0.88. What is the ratio of the Domestic credit (% of GDP) of Moldova in 2008 to that in 2009?
Make the answer very short. 1.01. What is the ratio of the Domestic credit (% of GDP) of Morocco in 2008 to that in 2009?
Your answer should be very brief. 0.96. What is the ratio of the Domestic credit (% of GDP) in Paraguay in 2008 to that in 2009?
Your answer should be compact. 0.82. What is the difference between the highest and the second highest Domestic credit (% of GDP) of Small states?
Ensure brevity in your answer.  4.49. What is the difference between the highest and the second highest Domestic credit (% of GDP) in Moldova?
Your answer should be very brief. 0.4. What is the difference between the highest and the second highest Domestic credit (% of GDP) in Morocco?
Make the answer very short. 2.6. What is the difference between the highest and the second highest Domestic credit (% of GDP) of Paraguay?
Provide a short and direct response. 5.33. What is the difference between the highest and the lowest Domestic credit (% of GDP) in Small states?
Your answer should be compact. 6.24. What is the difference between the highest and the lowest Domestic credit (% of GDP) of Moldova?
Your answer should be very brief. 15.62. What is the difference between the highest and the lowest Domestic credit (% of GDP) in Morocco?
Offer a terse response. 20.69. What is the difference between the highest and the lowest Domestic credit (% of GDP) in Paraguay?
Your answer should be very brief. 15.57. 